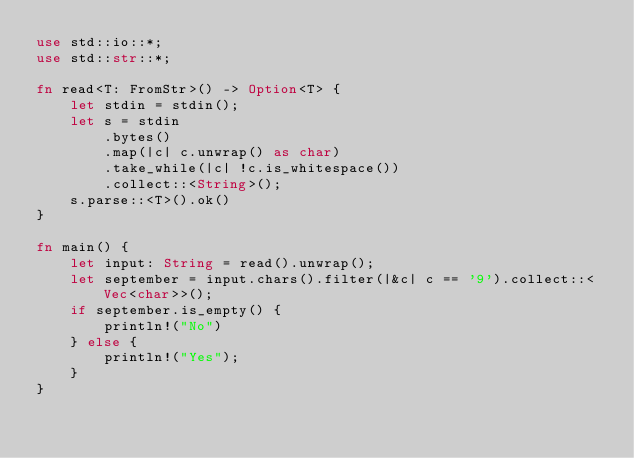<code> <loc_0><loc_0><loc_500><loc_500><_Rust_>use std::io::*;
use std::str::*;

fn read<T: FromStr>() -> Option<T> {
    let stdin = stdin();
    let s = stdin
        .bytes()
        .map(|c| c.unwrap() as char)
        .take_while(|c| !c.is_whitespace())
        .collect::<String>();
    s.parse::<T>().ok()
}

fn main() {
    let input: String = read().unwrap();
    let september = input.chars().filter(|&c| c == '9').collect::<Vec<char>>();
    if september.is_empty() {
        println!("No")
    } else {
        println!("Yes");
    }
}
</code> 